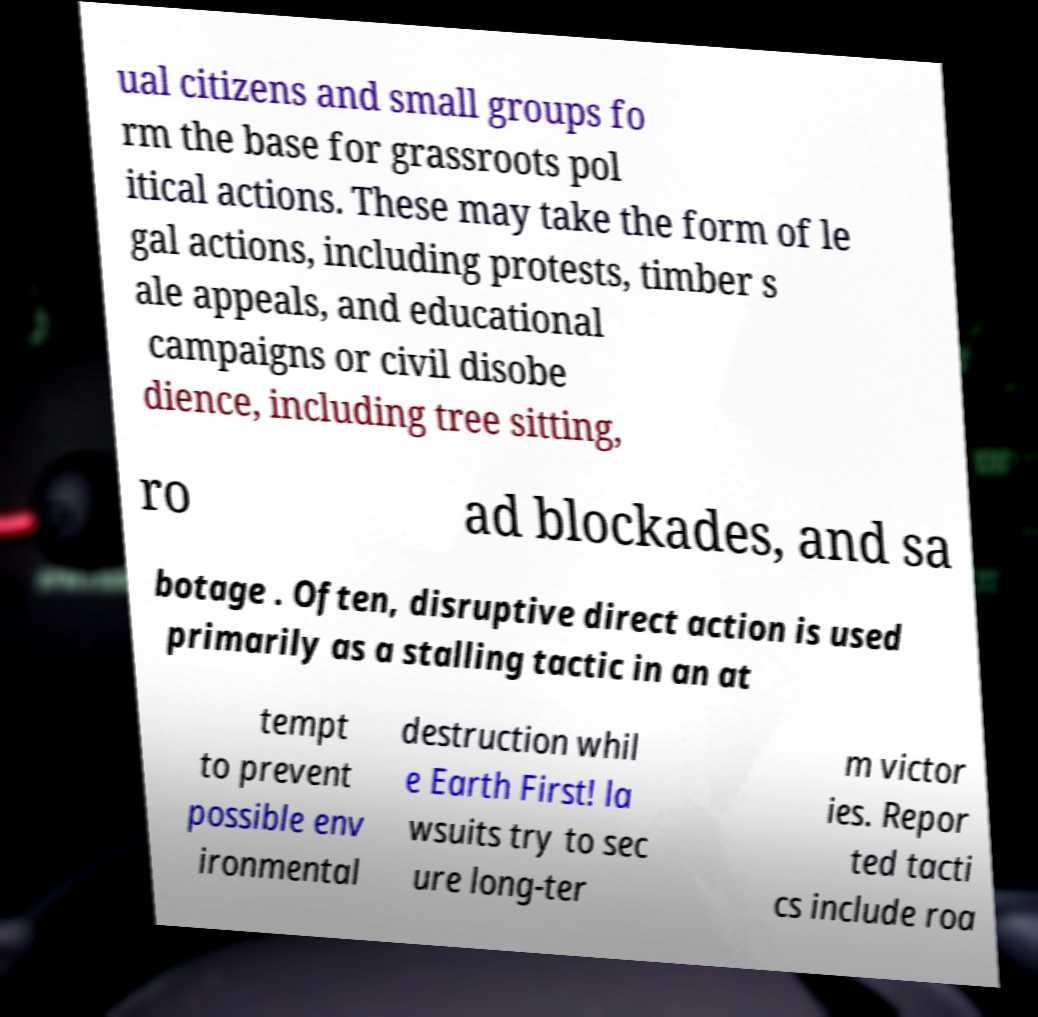Could you assist in decoding the text presented in this image and type it out clearly? ual citizens and small groups fo rm the base for grassroots pol itical actions. These may take the form of le gal actions, including protests, timber s ale appeals, and educational campaigns or civil disobe dience, including tree sitting, ro ad blockades, and sa botage . Often, disruptive direct action is used primarily as a stalling tactic in an at tempt to prevent possible env ironmental destruction whil e Earth First! la wsuits try to sec ure long-ter m victor ies. Repor ted tacti cs include roa 